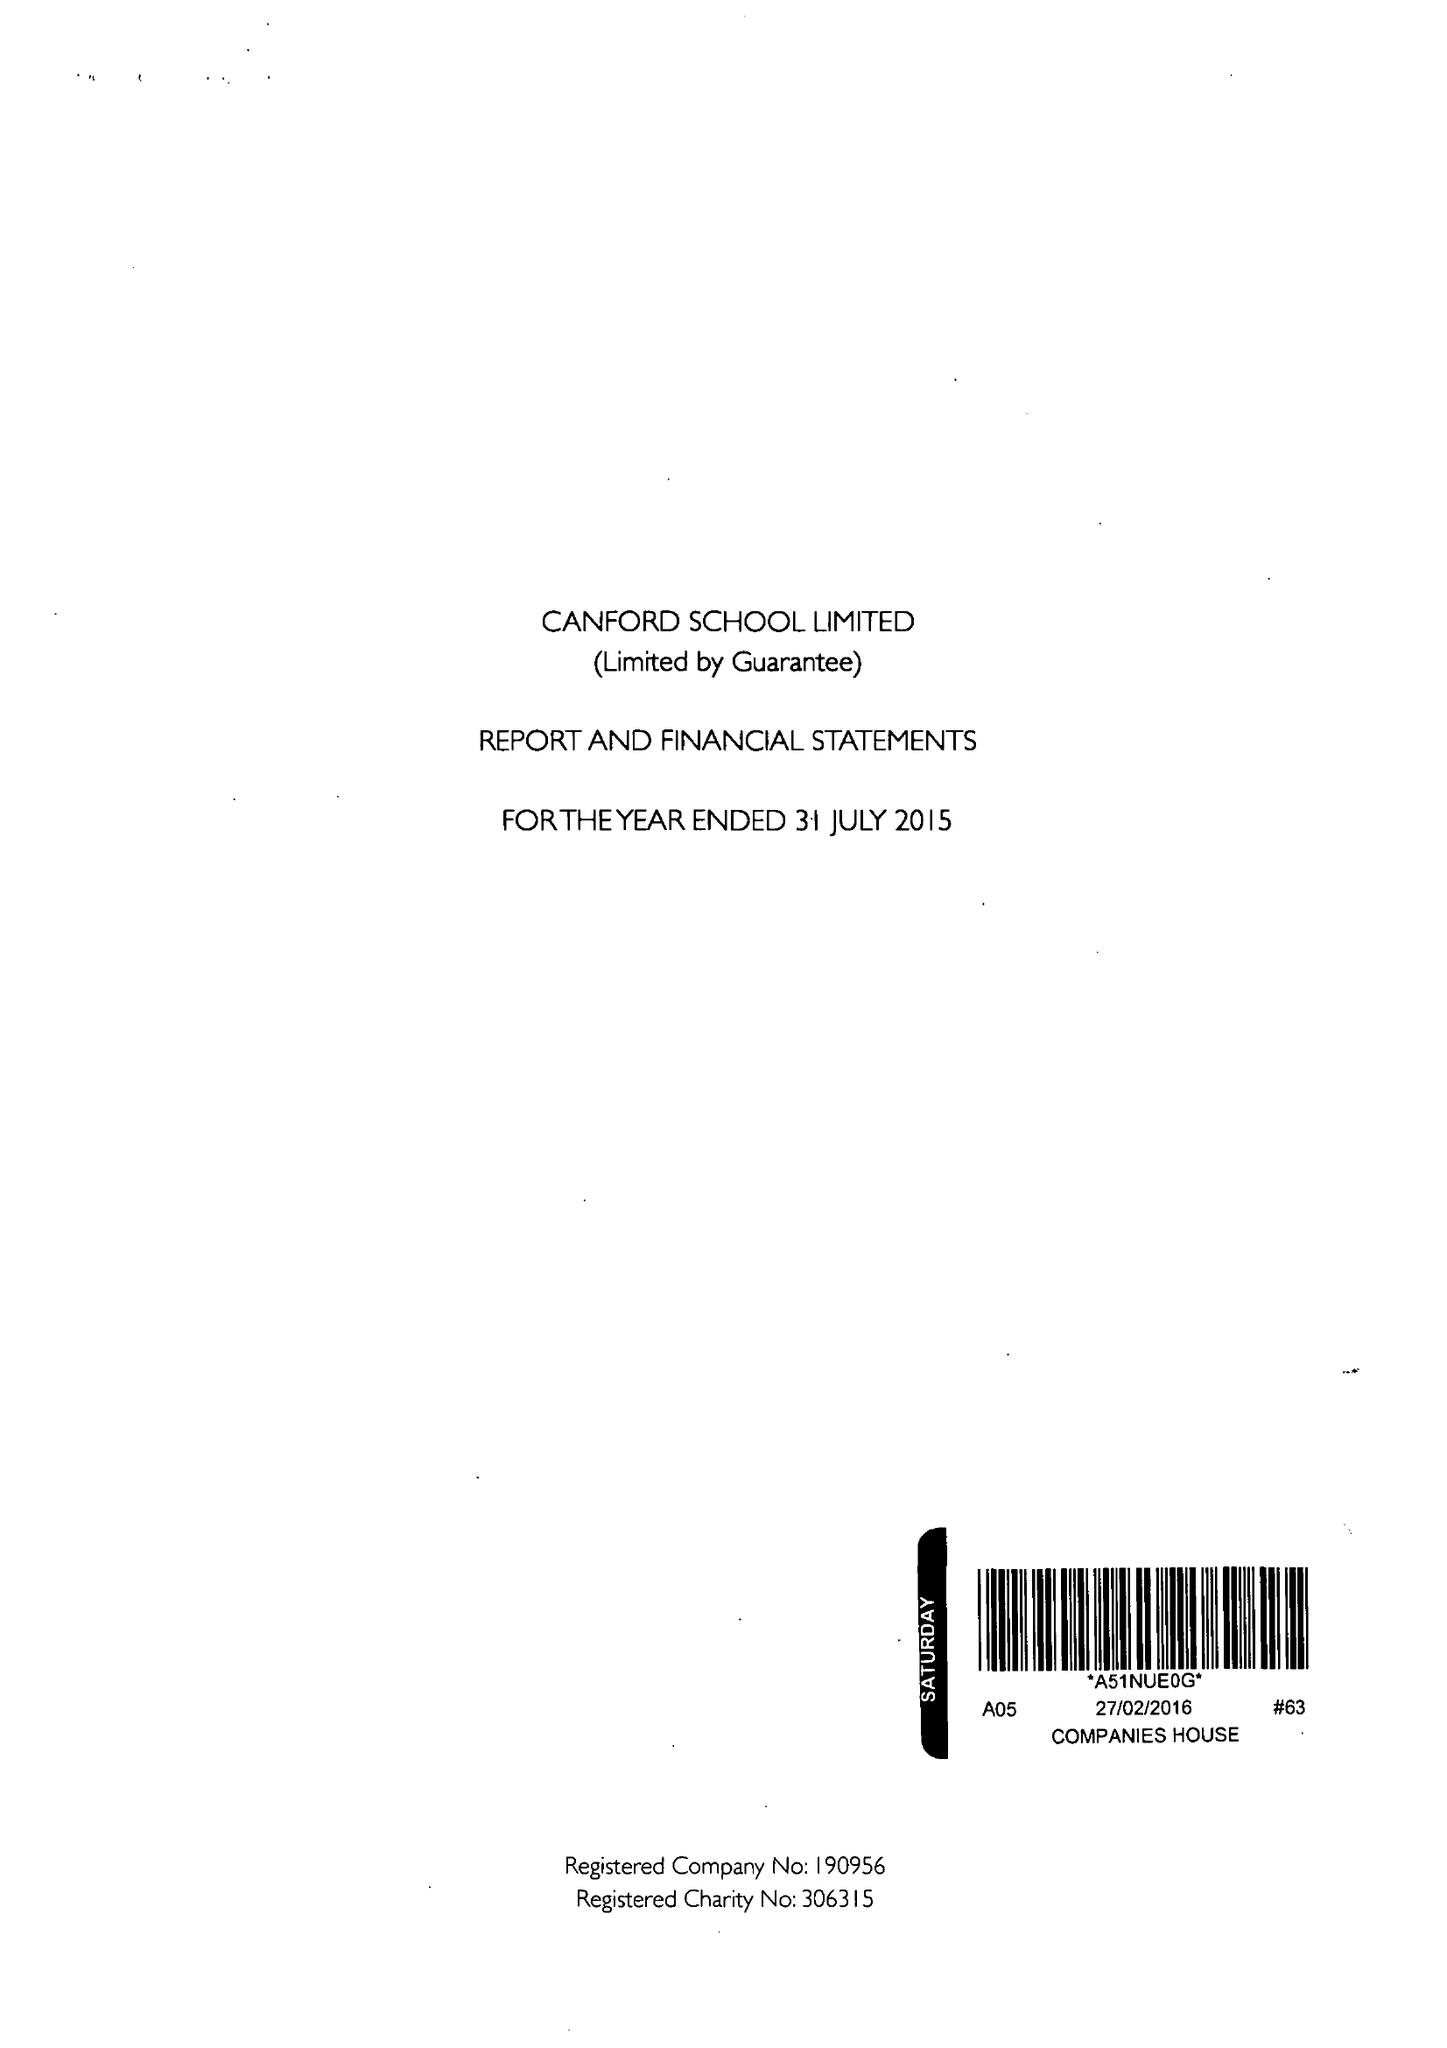What is the value for the income_annually_in_british_pounds?
Answer the question using a single word or phrase. 19895494.00 